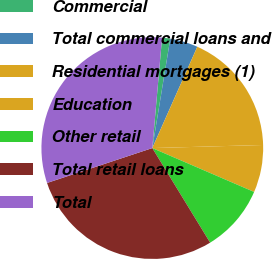Convert chart. <chart><loc_0><loc_0><loc_500><loc_500><pie_chart><fcel>Commercial<fcel>Total commercial loans and<fcel>Residential mortgages (1)<fcel>Education<fcel>Other retail<fcel>Total retail loans<fcel>Total<nl><fcel>1.19%<fcel>4.06%<fcel>17.9%<fcel>6.92%<fcel>9.79%<fcel>28.64%<fcel>31.5%<nl></chart> 